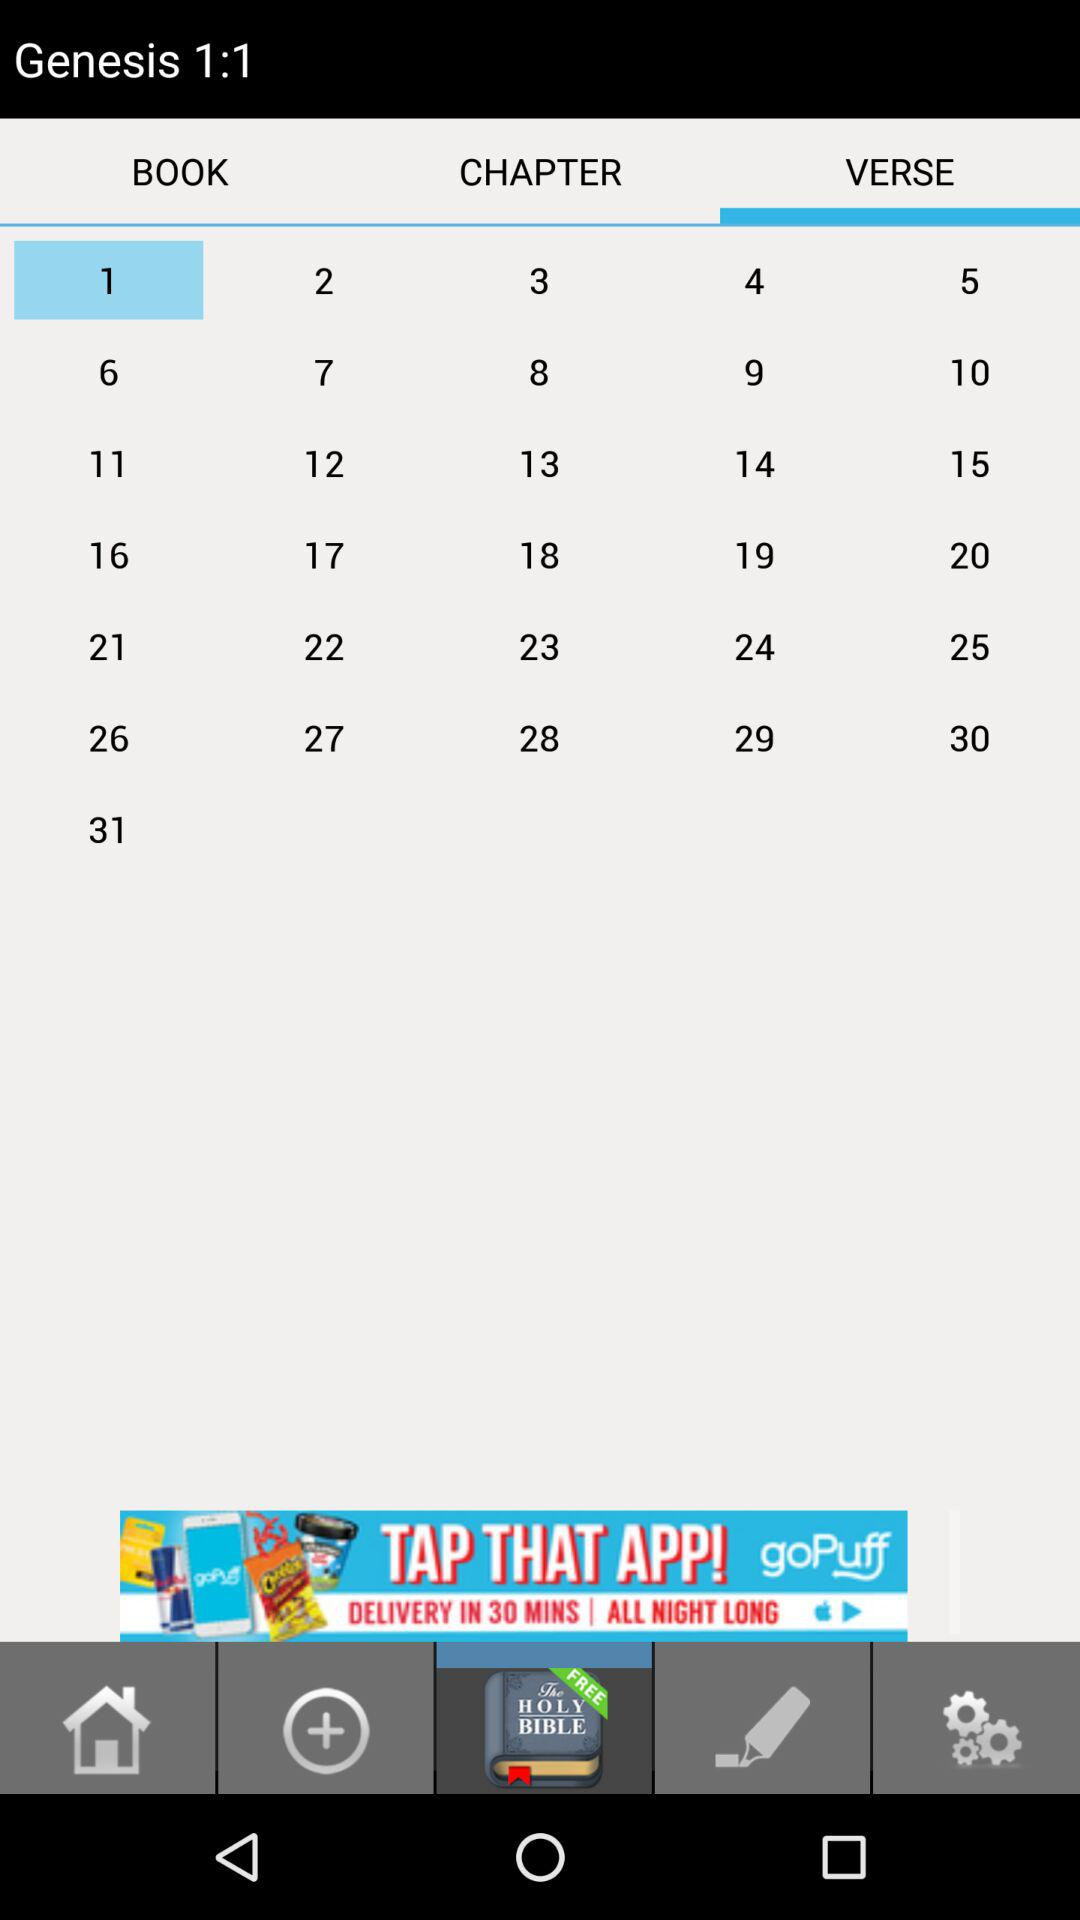Which chapter number of "Genesis" is there? The chapter number is 1. 